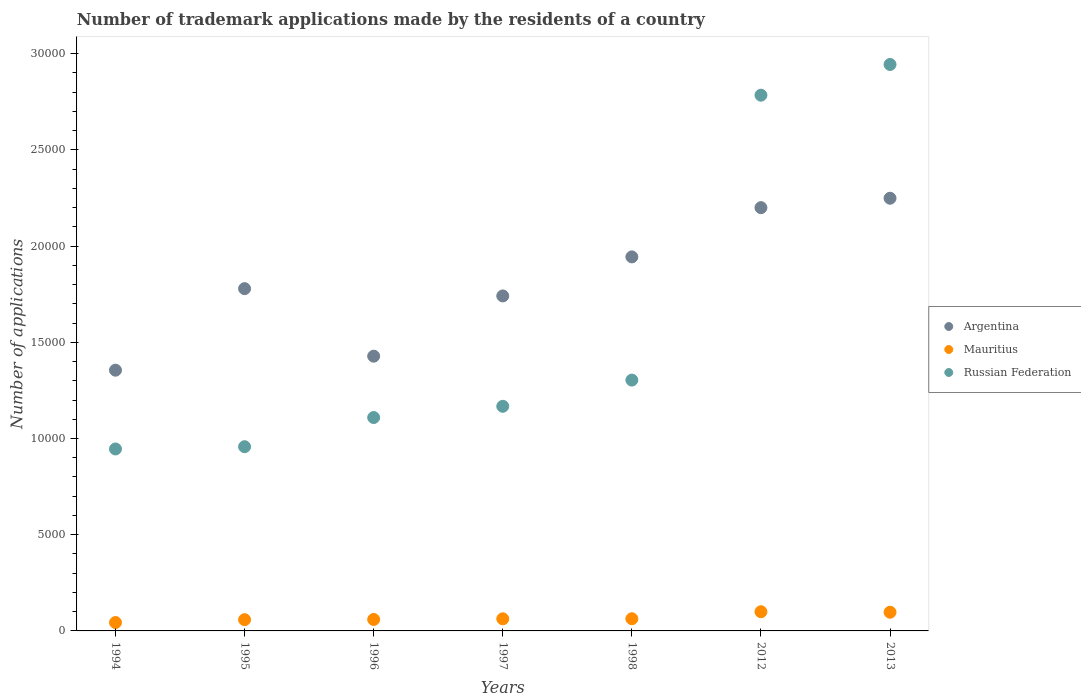What is the number of trademark applications made by the residents in Russian Federation in 1996?
Offer a terse response. 1.11e+04. Across all years, what is the maximum number of trademark applications made by the residents in Mauritius?
Ensure brevity in your answer.  997. Across all years, what is the minimum number of trademark applications made by the residents in Argentina?
Your answer should be very brief. 1.36e+04. In which year was the number of trademark applications made by the residents in Argentina maximum?
Provide a succinct answer. 2013. In which year was the number of trademark applications made by the residents in Argentina minimum?
Provide a succinct answer. 1994. What is the total number of trademark applications made by the residents in Russian Federation in the graph?
Ensure brevity in your answer.  1.12e+05. What is the difference between the number of trademark applications made by the residents in Argentina in 1994 and that in 2013?
Your answer should be very brief. -8936. What is the difference between the number of trademark applications made by the residents in Argentina in 1997 and the number of trademark applications made by the residents in Mauritius in 1996?
Provide a succinct answer. 1.68e+04. What is the average number of trademark applications made by the residents in Argentina per year?
Your response must be concise. 1.81e+04. In the year 2012, what is the difference between the number of trademark applications made by the residents in Mauritius and number of trademark applications made by the residents in Argentina?
Your answer should be compact. -2.10e+04. What is the ratio of the number of trademark applications made by the residents in Russian Federation in 2012 to that in 2013?
Offer a terse response. 0.95. Is the difference between the number of trademark applications made by the residents in Mauritius in 1996 and 1998 greater than the difference between the number of trademark applications made by the residents in Argentina in 1996 and 1998?
Keep it short and to the point. Yes. What is the difference between the highest and the lowest number of trademark applications made by the residents in Russian Federation?
Your answer should be very brief. 2.00e+04. Is it the case that in every year, the sum of the number of trademark applications made by the residents in Russian Federation and number of trademark applications made by the residents in Argentina  is greater than the number of trademark applications made by the residents in Mauritius?
Provide a short and direct response. Yes. Does the number of trademark applications made by the residents in Russian Federation monotonically increase over the years?
Offer a very short reply. Yes. How many dotlines are there?
Keep it short and to the point. 3. How many years are there in the graph?
Your response must be concise. 7. What is the difference between two consecutive major ticks on the Y-axis?
Ensure brevity in your answer.  5000. Are the values on the major ticks of Y-axis written in scientific E-notation?
Your answer should be very brief. No. Does the graph contain any zero values?
Ensure brevity in your answer.  No. Does the graph contain grids?
Offer a terse response. No. How many legend labels are there?
Provide a succinct answer. 3. What is the title of the graph?
Ensure brevity in your answer.  Number of trademark applications made by the residents of a country. What is the label or title of the Y-axis?
Make the answer very short. Number of applications. What is the Number of applications in Argentina in 1994?
Ensure brevity in your answer.  1.36e+04. What is the Number of applications of Mauritius in 1994?
Give a very brief answer. 437. What is the Number of applications in Russian Federation in 1994?
Offer a very short reply. 9456. What is the Number of applications of Argentina in 1995?
Your answer should be very brief. 1.78e+04. What is the Number of applications in Mauritius in 1995?
Keep it short and to the point. 585. What is the Number of applications of Russian Federation in 1995?
Provide a succinct answer. 9574. What is the Number of applications in Argentina in 1996?
Your answer should be very brief. 1.43e+04. What is the Number of applications in Mauritius in 1996?
Make the answer very short. 596. What is the Number of applications in Russian Federation in 1996?
Provide a short and direct response. 1.11e+04. What is the Number of applications of Argentina in 1997?
Keep it short and to the point. 1.74e+04. What is the Number of applications of Mauritius in 1997?
Offer a very short reply. 630. What is the Number of applications in Russian Federation in 1997?
Offer a very short reply. 1.17e+04. What is the Number of applications in Argentina in 1998?
Offer a terse response. 1.94e+04. What is the Number of applications of Mauritius in 1998?
Offer a very short reply. 633. What is the Number of applications of Russian Federation in 1998?
Give a very brief answer. 1.30e+04. What is the Number of applications of Argentina in 2012?
Ensure brevity in your answer.  2.20e+04. What is the Number of applications in Mauritius in 2012?
Ensure brevity in your answer.  997. What is the Number of applications of Russian Federation in 2012?
Offer a terse response. 2.78e+04. What is the Number of applications of Argentina in 2013?
Keep it short and to the point. 2.25e+04. What is the Number of applications of Mauritius in 2013?
Give a very brief answer. 971. What is the Number of applications in Russian Federation in 2013?
Provide a short and direct response. 2.94e+04. Across all years, what is the maximum Number of applications in Argentina?
Ensure brevity in your answer.  2.25e+04. Across all years, what is the maximum Number of applications of Mauritius?
Give a very brief answer. 997. Across all years, what is the maximum Number of applications of Russian Federation?
Give a very brief answer. 2.94e+04. Across all years, what is the minimum Number of applications of Argentina?
Ensure brevity in your answer.  1.36e+04. Across all years, what is the minimum Number of applications of Mauritius?
Ensure brevity in your answer.  437. Across all years, what is the minimum Number of applications of Russian Federation?
Provide a succinct answer. 9456. What is the total Number of applications of Argentina in the graph?
Offer a terse response. 1.27e+05. What is the total Number of applications in Mauritius in the graph?
Make the answer very short. 4849. What is the total Number of applications in Russian Federation in the graph?
Ensure brevity in your answer.  1.12e+05. What is the difference between the Number of applications of Argentina in 1994 and that in 1995?
Your response must be concise. -4237. What is the difference between the Number of applications of Mauritius in 1994 and that in 1995?
Offer a very short reply. -148. What is the difference between the Number of applications in Russian Federation in 1994 and that in 1995?
Provide a short and direct response. -118. What is the difference between the Number of applications in Argentina in 1994 and that in 1996?
Provide a short and direct response. -728. What is the difference between the Number of applications of Mauritius in 1994 and that in 1996?
Provide a succinct answer. -159. What is the difference between the Number of applications in Russian Federation in 1994 and that in 1996?
Make the answer very short. -1634. What is the difference between the Number of applications in Argentina in 1994 and that in 1997?
Ensure brevity in your answer.  -3859. What is the difference between the Number of applications in Mauritius in 1994 and that in 1997?
Give a very brief answer. -193. What is the difference between the Number of applications of Russian Federation in 1994 and that in 1997?
Ensure brevity in your answer.  -2218. What is the difference between the Number of applications of Argentina in 1994 and that in 1998?
Provide a short and direct response. -5888. What is the difference between the Number of applications in Mauritius in 1994 and that in 1998?
Keep it short and to the point. -196. What is the difference between the Number of applications in Russian Federation in 1994 and that in 1998?
Give a very brief answer. -3580. What is the difference between the Number of applications in Argentina in 1994 and that in 2012?
Your answer should be compact. -8447. What is the difference between the Number of applications in Mauritius in 1994 and that in 2012?
Keep it short and to the point. -560. What is the difference between the Number of applications in Russian Federation in 1994 and that in 2012?
Your answer should be compact. -1.84e+04. What is the difference between the Number of applications of Argentina in 1994 and that in 2013?
Provide a succinct answer. -8936. What is the difference between the Number of applications of Mauritius in 1994 and that in 2013?
Your answer should be compact. -534. What is the difference between the Number of applications of Russian Federation in 1994 and that in 2013?
Offer a terse response. -2.00e+04. What is the difference between the Number of applications in Argentina in 1995 and that in 1996?
Your answer should be very brief. 3509. What is the difference between the Number of applications of Mauritius in 1995 and that in 1996?
Your answer should be compact. -11. What is the difference between the Number of applications of Russian Federation in 1995 and that in 1996?
Offer a terse response. -1516. What is the difference between the Number of applications of Argentina in 1995 and that in 1997?
Offer a terse response. 378. What is the difference between the Number of applications in Mauritius in 1995 and that in 1997?
Ensure brevity in your answer.  -45. What is the difference between the Number of applications in Russian Federation in 1995 and that in 1997?
Give a very brief answer. -2100. What is the difference between the Number of applications of Argentina in 1995 and that in 1998?
Your answer should be compact. -1651. What is the difference between the Number of applications in Mauritius in 1995 and that in 1998?
Offer a very short reply. -48. What is the difference between the Number of applications in Russian Federation in 1995 and that in 1998?
Offer a very short reply. -3462. What is the difference between the Number of applications of Argentina in 1995 and that in 2012?
Offer a terse response. -4210. What is the difference between the Number of applications of Mauritius in 1995 and that in 2012?
Your answer should be compact. -412. What is the difference between the Number of applications of Russian Federation in 1995 and that in 2012?
Make the answer very short. -1.83e+04. What is the difference between the Number of applications in Argentina in 1995 and that in 2013?
Offer a terse response. -4699. What is the difference between the Number of applications in Mauritius in 1995 and that in 2013?
Ensure brevity in your answer.  -386. What is the difference between the Number of applications of Russian Federation in 1995 and that in 2013?
Your answer should be compact. -1.99e+04. What is the difference between the Number of applications in Argentina in 1996 and that in 1997?
Offer a very short reply. -3131. What is the difference between the Number of applications in Mauritius in 1996 and that in 1997?
Ensure brevity in your answer.  -34. What is the difference between the Number of applications in Russian Federation in 1996 and that in 1997?
Provide a succinct answer. -584. What is the difference between the Number of applications in Argentina in 1996 and that in 1998?
Keep it short and to the point. -5160. What is the difference between the Number of applications in Mauritius in 1996 and that in 1998?
Provide a short and direct response. -37. What is the difference between the Number of applications of Russian Federation in 1996 and that in 1998?
Give a very brief answer. -1946. What is the difference between the Number of applications of Argentina in 1996 and that in 2012?
Offer a very short reply. -7719. What is the difference between the Number of applications of Mauritius in 1996 and that in 2012?
Offer a terse response. -401. What is the difference between the Number of applications of Russian Federation in 1996 and that in 2012?
Your answer should be very brief. -1.68e+04. What is the difference between the Number of applications in Argentina in 1996 and that in 2013?
Give a very brief answer. -8208. What is the difference between the Number of applications of Mauritius in 1996 and that in 2013?
Your answer should be very brief. -375. What is the difference between the Number of applications in Russian Federation in 1996 and that in 2013?
Provide a succinct answer. -1.83e+04. What is the difference between the Number of applications in Argentina in 1997 and that in 1998?
Keep it short and to the point. -2029. What is the difference between the Number of applications of Mauritius in 1997 and that in 1998?
Offer a terse response. -3. What is the difference between the Number of applications of Russian Federation in 1997 and that in 1998?
Your answer should be compact. -1362. What is the difference between the Number of applications in Argentina in 1997 and that in 2012?
Ensure brevity in your answer.  -4588. What is the difference between the Number of applications of Mauritius in 1997 and that in 2012?
Offer a terse response. -367. What is the difference between the Number of applications of Russian Federation in 1997 and that in 2012?
Provide a short and direct response. -1.62e+04. What is the difference between the Number of applications of Argentina in 1997 and that in 2013?
Keep it short and to the point. -5077. What is the difference between the Number of applications in Mauritius in 1997 and that in 2013?
Your answer should be very brief. -341. What is the difference between the Number of applications of Russian Federation in 1997 and that in 2013?
Your answer should be compact. -1.78e+04. What is the difference between the Number of applications of Argentina in 1998 and that in 2012?
Your response must be concise. -2559. What is the difference between the Number of applications in Mauritius in 1998 and that in 2012?
Keep it short and to the point. -364. What is the difference between the Number of applications of Russian Federation in 1998 and that in 2012?
Provide a succinct answer. -1.48e+04. What is the difference between the Number of applications of Argentina in 1998 and that in 2013?
Keep it short and to the point. -3048. What is the difference between the Number of applications in Mauritius in 1998 and that in 2013?
Offer a terse response. -338. What is the difference between the Number of applications in Russian Federation in 1998 and that in 2013?
Your response must be concise. -1.64e+04. What is the difference between the Number of applications in Argentina in 2012 and that in 2013?
Your response must be concise. -489. What is the difference between the Number of applications of Russian Federation in 2012 and that in 2013?
Keep it short and to the point. -1596. What is the difference between the Number of applications of Argentina in 1994 and the Number of applications of Mauritius in 1995?
Ensure brevity in your answer.  1.30e+04. What is the difference between the Number of applications in Argentina in 1994 and the Number of applications in Russian Federation in 1995?
Offer a terse response. 3977. What is the difference between the Number of applications in Mauritius in 1994 and the Number of applications in Russian Federation in 1995?
Offer a terse response. -9137. What is the difference between the Number of applications of Argentina in 1994 and the Number of applications of Mauritius in 1996?
Provide a short and direct response. 1.30e+04. What is the difference between the Number of applications of Argentina in 1994 and the Number of applications of Russian Federation in 1996?
Your answer should be very brief. 2461. What is the difference between the Number of applications in Mauritius in 1994 and the Number of applications in Russian Federation in 1996?
Offer a very short reply. -1.07e+04. What is the difference between the Number of applications in Argentina in 1994 and the Number of applications in Mauritius in 1997?
Your answer should be very brief. 1.29e+04. What is the difference between the Number of applications of Argentina in 1994 and the Number of applications of Russian Federation in 1997?
Give a very brief answer. 1877. What is the difference between the Number of applications in Mauritius in 1994 and the Number of applications in Russian Federation in 1997?
Your answer should be very brief. -1.12e+04. What is the difference between the Number of applications of Argentina in 1994 and the Number of applications of Mauritius in 1998?
Offer a very short reply. 1.29e+04. What is the difference between the Number of applications of Argentina in 1994 and the Number of applications of Russian Federation in 1998?
Your answer should be compact. 515. What is the difference between the Number of applications of Mauritius in 1994 and the Number of applications of Russian Federation in 1998?
Your answer should be compact. -1.26e+04. What is the difference between the Number of applications in Argentina in 1994 and the Number of applications in Mauritius in 2012?
Provide a succinct answer. 1.26e+04. What is the difference between the Number of applications in Argentina in 1994 and the Number of applications in Russian Federation in 2012?
Make the answer very short. -1.43e+04. What is the difference between the Number of applications in Mauritius in 1994 and the Number of applications in Russian Federation in 2012?
Your response must be concise. -2.74e+04. What is the difference between the Number of applications in Argentina in 1994 and the Number of applications in Mauritius in 2013?
Your answer should be very brief. 1.26e+04. What is the difference between the Number of applications in Argentina in 1994 and the Number of applications in Russian Federation in 2013?
Offer a terse response. -1.59e+04. What is the difference between the Number of applications of Mauritius in 1994 and the Number of applications of Russian Federation in 2013?
Offer a very short reply. -2.90e+04. What is the difference between the Number of applications in Argentina in 1995 and the Number of applications in Mauritius in 1996?
Ensure brevity in your answer.  1.72e+04. What is the difference between the Number of applications in Argentina in 1995 and the Number of applications in Russian Federation in 1996?
Offer a very short reply. 6698. What is the difference between the Number of applications of Mauritius in 1995 and the Number of applications of Russian Federation in 1996?
Your answer should be compact. -1.05e+04. What is the difference between the Number of applications of Argentina in 1995 and the Number of applications of Mauritius in 1997?
Your response must be concise. 1.72e+04. What is the difference between the Number of applications of Argentina in 1995 and the Number of applications of Russian Federation in 1997?
Give a very brief answer. 6114. What is the difference between the Number of applications in Mauritius in 1995 and the Number of applications in Russian Federation in 1997?
Provide a short and direct response. -1.11e+04. What is the difference between the Number of applications of Argentina in 1995 and the Number of applications of Mauritius in 1998?
Offer a terse response. 1.72e+04. What is the difference between the Number of applications in Argentina in 1995 and the Number of applications in Russian Federation in 1998?
Provide a short and direct response. 4752. What is the difference between the Number of applications in Mauritius in 1995 and the Number of applications in Russian Federation in 1998?
Ensure brevity in your answer.  -1.25e+04. What is the difference between the Number of applications in Argentina in 1995 and the Number of applications in Mauritius in 2012?
Offer a very short reply. 1.68e+04. What is the difference between the Number of applications of Argentina in 1995 and the Number of applications of Russian Federation in 2012?
Give a very brief answer. -1.01e+04. What is the difference between the Number of applications in Mauritius in 1995 and the Number of applications in Russian Federation in 2012?
Your response must be concise. -2.73e+04. What is the difference between the Number of applications in Argentina in 1995 and the Number of applications in Mauritius in 2013?
Make the answer very short. 1.68e+04. What is the difference between the Number of applications in Argentina in 1995 and the Number of applications in Russian Federation in 2013?
Offer a very short reply. -1.17e+04. What is the difference between the Number of applications in Mauritius in 1995 and the Number of applications in Russian Federation in 2013?
Your answer should be very brief. -2.89e+04. What is the difference between the Number of applications in Argentina in 1996 and the Number of applications in Mauritius in 1997?
Your response must be concise. 1.36e+04. What is the difference between the Number of applications in Argentina in 1996 and the Number of applications in Russian Federation in 1997?
Offer a terse response. 2605. What is the difference between the Number of applications in Mauritius in 1996 and the Number of applications in Russian Federation in 1997?
Your answer should be compact. -1.11e+04. What is the difference between the Number of applications in Argentina in 1996 and the Number of applications in Mauritius in 1998?
Give a very brief answer. 1.36e+04. What is the difference between the Number of applications in Argentina in 1996 and the Number of applications in Russian Federation in 1998?
Offer a very short reply. 1243. What is the difference between the Number of applications of Mauritius in 1996 and the Number of applications of Russian Federation in 1998?
Your answer should be compact. -1.24e+04. What is the difference between the Number of applications of Argentina in 1996 and the Number of applications of Mauritius in 2012?
Offer a terse response. 1.33e+04. What is the difference between the Number of applications of Argentina in 1996 and the Number of applications of Russian Federation in 2012?
Offer a very short reply. -1.36e+04. What is the difference between the Number of applications of Mauritius in 1996 and the Number of applications of Russian Federation in 2012?
Your answer should be very brief. -2.72e+04. What is the difference between the Number of applications of Argentina in 1996 and the Number of applications of Mauritius in 2013?
Keep it short and to the point. 1.33e+04. What is the difference between the Number of applications of Argentina in 1996 and the Number of applications of Russian Federation in 2013?
Provide a short and direct response. -1.52e+04. What is the difference between the Number of applications of Mauritius in 1996 and the Number of applications of Russian Federation in 2013?
Keep it short and to the point. -2.88e+04. What is the difference between the Number of applications of Argentina in 1997 and the Number of applications of Mauritius in 1998?
Make the answer very short. 1.68e+04. What is the difference between the Number of applications of Argentina in 1997 and the Number of applications of Russian Federation in 1998?
Keep it short and to the point. 4374. What is the difference between the Number of applications in Mauritius in 1997 and the Number of applications in Russian Federation in 1998?
Give a very brief answer. -1.24e+04. What is the difference between the Number of applications of Argentina in 1997 and the Number of applications of Mauritius in 2012?
Provide a succinct answer. 1.64e+04. What is the difference between the Number of applications in Argentina in 1997 and the Number of applications in Russian Federation in 2012?
Provide a succinct answer. -1.04e+04. What is the difference between the Number of applications in Mauritius in 1997 and the Number of applications in Russian Federation in 2012?
Provide a short and direct response. -2.72e+04. What is the difference between the Number of applications of Argentina in 1997 and the Number of applications of Mauritius in 2013?
Offer a very short reply. 1.64e+04. What is the difference between the Number of applications in Argentina in 1997 and the Number of applications in Russian Federation in 2013?
Your answer should be very brief. -1.20e+04. What is the difference between the Number of applications of Mauritius in 1997 and the Number of applications of Russian Federation in 2013?
Your answer should be very brief. -2.88e+04. What is the difference between the Number of applications in Argentina in 1998 and the Number of applications in Mauritius in 2012?
Your answer should be compact. 1.84e+04. What is the difference between the Number of applications in Argentina in 1998 and the Number of applications in Russian Federation in 2012?
Your response must be concise. -8404. What is the difference between the Number of applications in Mauritius in 1998 and the Number of applications in Russian Federation in 2012?
Offer a terse response. -2.72e+04. What is the difference between the Number of applications in Argentina in 1998 and the Number of applications in Mauritius in 2013?
Provide a succinct answer. 1.85e+04. What is the difference between the Number of applications in Argentina in 1998 and the Number of applications in Russian Federation in 2013?
Ensure brevity in your answer.  -10000. What is the difference between the Number of applications in Mauritius in 1998 and the Number of applications in Russian Federation in 2013?
Provide a short and direct response. -2.88e+04. What is the difference between the Number of applications of Argentina in 2012 and the Number of applications of Mauritius in 2013?
Provide a succinct answer. 2.10e+04. What is the difference between the Number of applications of Argentina in 2012 and the Number of applications of Russian Federation in 2013?
Your answer should be very brief. -7441. What is the difference between the Number of applications in Mauritius in 2012 and the Number of applications in Russian Federation in 2013?
Your answer should be compact. -2.84e+04. What is the average Number of applications of Argentina per year?
Your response must be concise. 1.81e+04. What is the average Number of applications in Mauritius per year?
Provide a short and direct response. 692.71. What is the average Number of applications in Russian Federation per year?
Make the answer very short. 1.60e+04. In the year 1994, what is the difference between the Number of applications in Argentina and Number of applications in Mauritius?
Provide a short and direct response. 1.31e+04. In the year 1994, what is the difference between the Number of applications of Argentina and Number of applications of Russian Federation?
Offer a terse response. 4095. In the year 1994, what is the difference between the Number of applications of Mauritius and Number of applications of Russian Federation?
Provide a succinct answer. -9019. In the year 1995, what is the difference between the Number of applications in Argentina and Number of applications in Mauritius?
Ensure brevity in your answer.  1.72e+04. In the year 1995, what is the difference between the Number of applications of Argentina and Number of applications of Russian Federation?
Offer a very short reply. 8214. In the year 1995, what is the difference between the Number of applications of Mauritius and Number of applications of Russian Federation?
Provide a short and direct response. -8989. In the year 1996, what is the difference between the Number of applications in Argentina and Number of applications in Mauritius?
Your answer should be compact. 1.37e+04. In the year 1996, what is the difference between the Number of applications of Argentina and Number of applications of Russian Federation?
Your response must be concise. 3189. In the year 1996, what is the difference between the Number of applications in Mauritius and Number of applications in Russian Federation?
Your answer should be very brief. -1.05e+04. In the year 1997, what is the difference between the Number of applications in Argentina and Number of applications in Mauritius?
Give a very brief answer. 1.68e+04. In the year 1997, what is the difference between the Number of applications in Argentina and Number of applications in Russian Federation?
Ensure brevity in your answer.  5736. In the year 1997, what is the difference between the Number of applications in Mauritius and Number of applications in Russian Federation?
Ensure brevity in your answer.  -1.10e+04. In the year 1998, what is the difference between the Number of applications in Argentina and Number of applications in Mauritius?
Make the answer very short. 1.88e+04. In the year 1998, what is the difference between the Number of applications in Argentina and Number of applications in Russian Federation?
Offer a terse response. 6403. In the year 1998, what is the difference between the Number of applications in Mauritius and Number of applications in Russian Federation?
Provide a short and direct response. -1.24e+04. In the year 2012, what is the difference between the Number of applications in Argentina and Number of applications in Mauritius?
Your response must be concise. 2.10e+04. In the year 2012, what is the difference between the Number of applications in Argentina and Number of applications in Russian Federation?
Provide a succinct answer. -5845. In the year 2012, what is the difference between the Number of applications of Mauritius and Number of applications of Russian Federation?
Provide a short and direct response. -2.68e+04. In the year 2013, what is the difference between the Number of applications in Argentina and Number of applications in Mauritius?
Offer a very short reply. 2.15e+04. In the year 2013, what is the difference between the Number of applications in Argentina and Number of applications in Russian Federation?
Make the answer very short. -6952. In the year 2013, what is the difference between the Number of applications of Mauritius and Number of applications of Russian Federation?
Ensure brevity in your answer.  -2.85e+04. What is the ratio of the Number of applications of Argentina in 1994 to that in 1995?
Make the answer very short. 0.76. What is the ratio of the Number of applications in Mauritius in 1994 to that in 1995?
Give a very brief answer. 0.75. What is the ratio of the Number of applications in Russian Federation in 1994 to that in 1995?
Provide a short and direct response. 0.99. What is the ratio of the Number of applications of Argentina in 1994 to that in 1996?
Your response must be concise. 0.95. What is the ratio of the Number of applications of Mauritius in 1994 to that in 1996?
Give a very brief answer. 0.73. What is the ratio of the Number of applications in Russian Federation in 1994 to that in 1996?
Keep it short and to the point. 0.85. What is the ratio of the Number of applications in Argentina in 1994 to that in 1997?
Provide a succinct answer. 0.78. What is the ratio of the Number of applications of Mauritius in 1994 to that in 1997?
Ensure brevity in your answer.  0.69. What is the ratio of the Number of applications of Russian Federation in 1994 to that in 1997?
Make the answer very short. 0.81. What is the ratio of the Number of applications of Argentina in 1994 to that in 1998?
Ensure brevity in your answer.  0.7. What is the ratio of the Number of applications of Mauritius in 1994 to that in 1998?
Provide a short and direct response. 0.69. What is the ratio of the Number of applications in Russian Federation in 1994 to that in 1998?
Provide a succinct answer. 0.73. What is the ratio of the Number of applications of Argentina in 1994 to that in 2012?
Provide a succinct answer. 0.62. What is the ratio of the Number of applications of Mauritius in 1994 to that in 2012?
Provide a short and direct response. 0.44. What is the ratio of the Number of applications in Russian Federation in 1994 to that in 2012?
Provide a short and direct response. 0.34. What is the ratio of the Number of applications of Argentina in 1994 to that in 2013?
Offer a very short reply. 0.6. What is the ratio of the Number of applications of Mauritius in 1994 to that in 2013?
Make the answer very short. 0.45. What is the ratio of the Number of applications in Russian Federation in 1994 to that in 2013?
Your answer should be very brief. 0.32. What is the ratio of the Number of applications in Argentina in 1995 to that in 1996?
Provide a short and direct response. 1.25. What is the ratio of the Number of applications in Mauritius in 1995 to that in 1996?
Make the answer very short. 0.98. What is the ratio of the Number of applications in Russian Federation in 1995 to that in 1996?
Make the answer very short. 0.86. What is the ratio of the Number of applications in Argentina in 1995 to that in 1997?
Your response must be concise. 1.02. What is the ratio of the Number of applications of Russian Federation in 1995 to that in 1997?
Ensure brevity in your answer.  0.82. What is the ratio of the Number of applications of Argentina in 1995 to that in 1998?
Offer a terse response. 0.92. What is the ratio of the Number of applications of Mauritius in 1995 to that in 1998?
Give a very brief answer. 0.92. What is the ratio of the Number of applications in Russian Federation in 1995 to that in 1998?
Your answer should be compact. 0.73. What is the ratio of the Number of applications in Argentina in 1995 to that in 2012?
Ensure brevity in your answer.  0.81. What is the ratio of the Number of applications of Mauritius in 1995 to that in 2012?
Make the answer very short. 0.59. What is the ratio of the Number of applications in Russian Federation in 1995 to that in 2012?
Provide a succinct answer. 0.34. What is the ratio of the Number of applications of Argentina in 1995 to that in 2013?
Ensure brevity in your answer.  0.79. What is the ratio of the Number of applications in Mauritius in 1995 to that in 2013?
Your answer should be very brief. 0.6. What is the ratio of the Number of applications of Russian Federation in 1995 to that in 2013?
Your answer should be very brief. 0.33. What is the ratio of the Number of applications of Argentina in 1996 to that in 1997?
Offer a terse response. 0.82. What is the ratio of the Number of applications of Mauritius in 1996 to that in 1997?
Offer a terse response. 0.95. What is the ratio of the Number of applications of Russian Federation in 1996 to that in 1997?
Your answer should be compact. 0.95. What is the ratio of the Number of applications of Argentina in 1996 to that in 1998?
Provide a short and direct response. 0.73. What is the ratio of the Number of applications of Mauritius in 1996 to that in 1998?
Provide a short and direct response. 0.94. What is the ratio of the Number of applications in Russian Federation in 1996 to that in 1998?
Ensure brevity in your answer.  0.85. What is the ratio of the Number of applications of Argentina in 1996 to that in 2012?
Your response must be concise. 0.65. What is the ratio of the Number of applications of Mauritius in 1996 to that in 2012?
Ensure brevity in your answer.  0.6. What is the ratio of the Number of applications in Russian Federation in 1996 to that in 2012?
Provide a succinct answer. 0.4. What is the ratio of the Number of applications of Argentina in 1996 to that in 2013?
Keep it short and to the point. 0.64. What is the ratio of the Number of applications in Mauritius in 1996 to that in 2013?
Provide a short and direct response. 0.61. What is the ratio of the Number of applications of Russian Federation in 1996 to that in 2013?
Offer a very short reply. 0.38. What is the ratio of the Number of applications of Argentina in 1997 to that in 1998?
Provide a short and direct response. 0.9. What is the ratio of the Number of applications of Mauritius in 1997 to that in 1998?
Ensure brevity in your answer.  1. What is the ratio of the Number of applications in Russian Federation in 1997 to that in 1998?
Ensure brevity in your answer.  0.9. What is the ratio of the Number of applications of Argentina in 1997 to that in 2012?
Offer a terse response. 0.79. What is the ratio of the Number of applications of Mauritius in 1997 to that in 2012?
Your answer should be compact. 0.63. What is the ratio of the Number of applications of Russian Federation in 1997 to that in 2012?
Offer a terse response. 0.42. What is the ratio of the Number of applications of Argentina in 1997 to that in 2013?
Provide a succinct answer. 0.77. What is the ratio of the Number of applications of Mauritius in 1997 to that in 2013?
Ensure brevity in your answer.  0.65. What is the ratio of the Number of applications of Russian Federation in 1997 to that in 2013?
Your answer should be very brief. 0.4. What is the ratio of the Number of applications of Argentina in 1998 to that in 2012?
Provide a succinct answer. 0.88. What is the ratio of the Number of applications in Mauritius in 1998 to that in 2012?
Your answer should be very brief. 0.63. What is the ratio of the Number of applications of Russian Federation in 1998 to that in 2012?
Keep it short and to the point. 0.47. What is the ratio of the Number of applications of Argentina in 1998 to that in 2013?
Offer a very short reply. 0.86. What is the ratio of the Number of applications of Mauritius in 1998 to that in 2013?
Your answer should be very brief. 0.65. What is the ratio of the Number of applications of Russian Federation in 1998 to that in 2013?
Keep it short and to the point. 0.44. What is the ratio of the Number of applications of Argentina in 2012 to that in 2013?
Provide a short and direct response. 0.98. What is the ratio of the Number of applications in Mauritius in 2012 to that in 2013?
Offer a terse response. 1.03. What is the ratio of the Number of applications of Russian Federation in 2012 to that in 2013?
Offer a terse response. 0.95. What is the difference between the highest and the second highest Number of applications in Argentina?
Provide a short and direct response. 489. What is the difference between the highest and the second highest Number of applications of Mauritius?
Provide a succinct answer. 26. What is the difference between the highest and the second highest Number of applications of Russian Federation?
Your response must be concise. 1596. What is the difference between the highest and the lowest Number of applications in Argentina?
Provide a short and direct response. 8936. What is the difference between the highest and the lowest Number of applications in Mauritius?
Your answer should be compact. 560. What is the difference between the highest and the lowest Number of applications of Russian Federation?
Your answer should be very brief. 2.00e+04. 